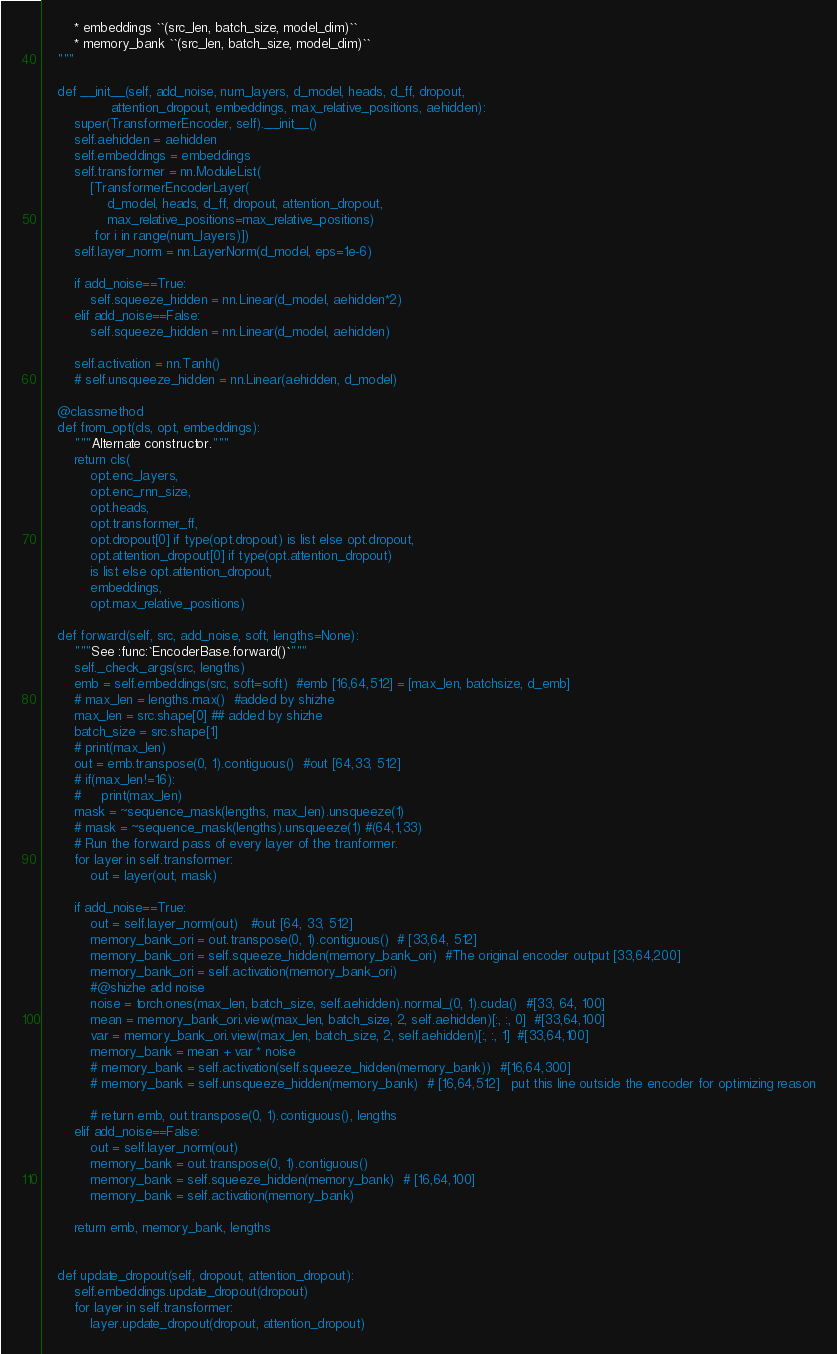<code> <loc_0><loc_0><loc_500><loc_500><_Python_>        * embeddings ``(src_len, batch_size, model_dim)``
        * memory_bank ``(src_len, batch_size, model_dim)``
    """

    def __init__(self, add_noise, num_layers, d_model, heads, d_ff, dropout,
                 attention_dropout, embeddings, max_relative_positions, aehidden):
        super(TransformerEncoder, self).__init__()
        self.aehidden = aehidden
        self.embeddings = embeddings
        self.transformer = nn.ModuleList(
            [TransformerEncoderLayer(
                d_model, heads, d_ff, dropout, attention_dropout,
                max_relative_positions=max_relative_positions)
             for i in range(num_layers)])
        self.layer_norm = nn.LayerNorm(d_model, eps=1e-6)

        if add_noise==True:
            self.squeeze_hidden = nn.Linear(d_model, aehidden*2)
        elif add_noise==False:
            self.squeeze_hidden = nn.Linear(d_model, aehidden)

        self.activation = nn.Tanh()
        # self.unsqueeze_hidden = nn.Linear(aehidden, d_model)

    @classmethod
    def from_opt(cls, opt, embeddings):
        """Alternate constructor."""
        return cls(
            opt.enc_layers,
            opt.enc_rnn_size,
            opt.heads,
            opt.transformer_ff,
            opt.dropout[0] if type(opt.dropout) is list else opt.dropout,
            opt.attention_dropout[0] if type(opt.attention_dropout)
            is list else opt.attention_dropout,
            embeddings,
            opt.max_relative_positions)

    def forward(self, src, add_noise, soft, lengths=None):
        """See :func:`EncoderBase.forward()`"""
        self._check_args(src, lengths)
        emb = self.embeddings(src, soft=soft)  #emb [16,64,512] = [max_len, batchsize, d_emb]
        # max_len = lengths.max()  #added by shizhe
        max_len = src.shape[0] ## added by shizhe
        batch_size = src.shape[1]
        # print(max_len)
        out = emb.transpose(0, 1).contiguous()  #out [64,33, 512]
        # if(max_len!=16):
        #     print(max_len)
        mask = ~sequence_mask(lengths, max_len).unsqueeze(1)
        # mask = ~sequence_mask(lengths).unsqueeze(1) #(64,1,33)
        # Run the forward pass of every layer of the tranformer.
        for layer in self.transformer:
            out = layer(out, mask)

        if add_noise==True:
            out = self.layer_norm(out)   #out [64, 33, 512]
            memory_bank_ori = out.transpose(0, 1).contiguous()  # [33,64, 512]
            memory_bank_ori = self.squeeze_hidden(memory_bank_ori)  #The original encoder output [33,64,200]
            memory_bank_ori = self.activation(memory_bank_ori)
            #@shizhe add noise
            noise = torch.ones(max_len, batch_size, self.aehidden).normal_(0, 1).cuda()  #[33, 64, 100]
            mean = memory_bank_ori.view(max_len, batch_size, 2, self.aehidden)[:, :, 0]  #[33,64,100]
            var = memory_bank_ori.view(max_len, batch_size, 2, self.aehidden)[:, :, 1]  #[33,64,100]
            memory_bank = mean + var * noise
            # memory_bank = self.activation(self.squeeze_hidden(memory_bank))  #[16,64,300]
            # memory_bank = self.unsqueeze_hidden(memory_bank)  # [16,64,512]   put this line outside the encoder for optimizing reason

            # return emb, out.transpose(0, 1).contiguous(), lengths
        elif add_noise==False:
            out = self.layer_norm(out)
            memory_bank = out.transpose(0, 1).contiguous()
            memory_bank = self.squeeze_hidden(memory_bank)  # [16,64,100]
            memory_bank = self.activation(memory_bank)

        return emb, memory_bank, lengths


    def update_dropout(self, dropout, attention_dropout):
        self.embeddings.update_dropout(dropout)
        for layer in self.transformer:
            layer.update_dropout(dropout, attention_dropout)
</code> 